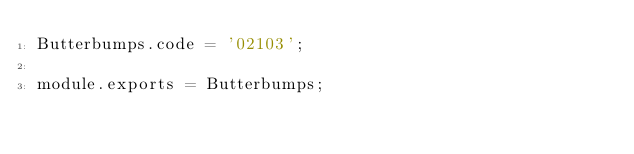Convert code to text. <code><loc_0><loc_0><loc_500><loc_500><_JavaScript_>Butterbumps.code = '02103';

module.exports = Butterbumps;
</code> 